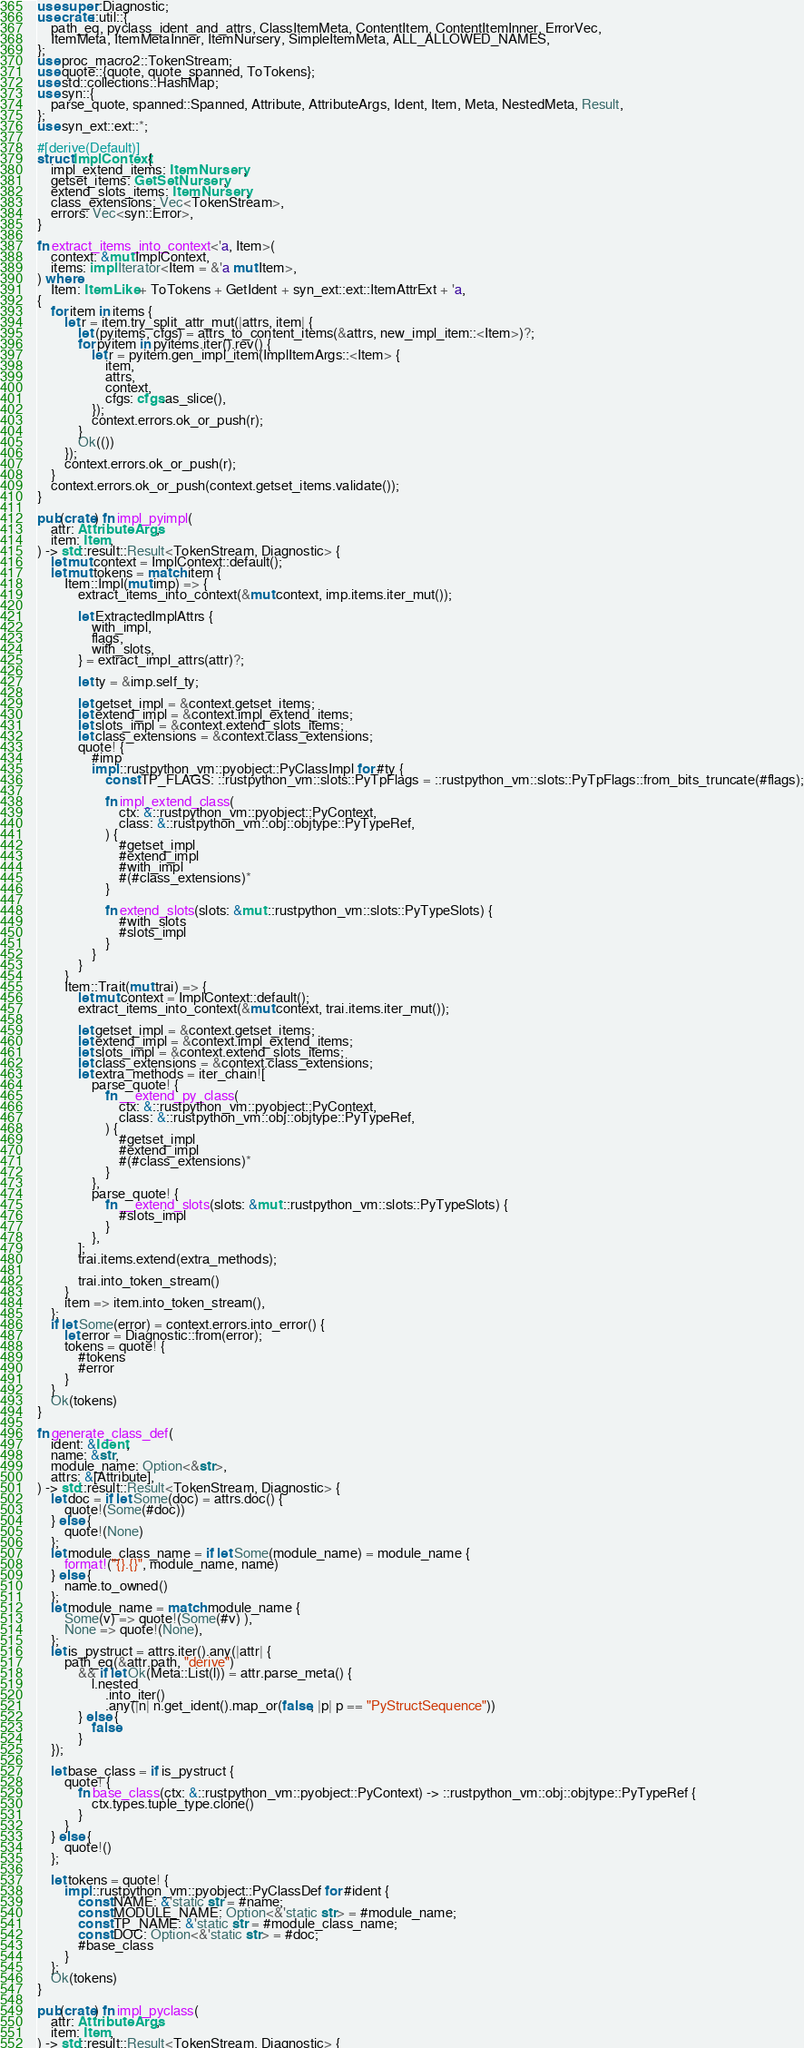Convert code to text. <code><loc_0><loc_0><loc_500><loc_500><_Rust_>use super::Diagnostic;
use crate::util::{
    path_eq, pyclass_ident_and_attrs, ClassItemMeta, ContentItem, ContentItemInner, ErrorVec,
    ItemMeta, ItemMetaInner, ItemNursery, SimpleItemMeta, ALL_ALLOWED_NAMES,
};
use proc_macro2::TokenStream;
use quote::{quote, quote_spanned, ToTokens};
use std::collections::HashMap;
use syn::{
    parse_quote, spanned::Spanned, Attribute, AttributeArgs, Ident, Item, Meta, NestedMeta, Result,
};
use syn_ext::ext::*;

#[derive(Default)]
struct ImplContext {
    impl_extend_items: ItemNursery,
    getset_items: GetSetNursery,
    extend_slots_items: ItemNursery,
    class_extensions: Vec<TokenStream>,
    errors: Vec<syn::Error>,
}

fn extract_items_into_context<'a, Item>(
    context: &mut ImplContext,
    items: impl Iterator<Item = &'a mut Item>,
) where
    Item: ItemLike + ToTokens + GetIdent + syn_ext::ext::ItemAttrExt + 'a,
{
    for item in items {
        let r = item.try_split_attr_mut(|attrs, item| {
            let (pyitems, cfgs) = attrs_to_content_items(&attrs, new_impl_item::<Item>)?;
            for pyitem in pyitems.iter().rev() {
                let r = pyitem.gen_impl_item(ImplItemArgs::<Item> {
                    item,
                    attrs,
                    context,
                    cfgs: cfgs.as_slice(),
                });
                context.errors.ok_or_push(r);
            }
            Ok(())
        });
        context.errors.ok_or_push(r);
    }
    context.errors.ok_or_push(context.getset_items.validate());
}

pub(crate) fn impl_pyimpl(
    attr: AttributeArgs,
    item: Item,
) -> std::result::Result<TokenStream, Diagnostic> {
    let mut context = ImplContext::default();
    let mut tokens = match item {
        Item::Impl(mut imp) => {
            extract_items_into_context(&mut context, imp.items.iter_mut());

            let ExtractedImplAttrs {
                with_impl,
                flags,
                with_slots,
            } = extract_impl_attrs(attr)?;

            let ty = &imp.self_ty;

            let getset_impl = &context.getset_items;
            let extend_impl = &context.impl_extend_items;
            let slots_impl = &context.extend_slots_items;
            let class_extensions = &context.class_extensions;
            quote! {
                #imp
                impl ::rustpython_vm::pyobject::PyClassImpl for #ty {
                    const TP_FLAGS: ::rustpython_vm::slots::PyTpFlags = ::rustpython_vm::slots::PyTpFlags::from_bits_truncate(#flags);

                    fn impl_extend_class(
                        ctx: &::rustpython_vm::pyobject::PyContext,
                        class: &::rustpython_vm::obj::objtype::PyTypeRef,
                    ) {
                        #getset_impl
                        #extend_impl
                        #with_impl
                        #(#class_extensions)*
                    }

                    fn extend_slots(slots: &mut ::rustpython_vm::slots::PyTypeSlots) {
                        #with_slots
                        #slots_impl
                    }
                }
            }
        }
        Item::Trait(mut trai) => {
            let mut context = ImplContext::default();
            extract_items_into_context(&mut context, trai.items.iter_mut());

            let getset_impl = &context.getset_items;
            let extend_impl = &context.impl_extend_items;
            let slots_impl = &context.extend_slots_items;
            let class_extensions = &context.class_extensions;
            let extra_methods = iter_chain![
                parse_quote! {
                    fn __extend_py_class(
                        ctx: &::rustpython_vm::pyobject::PyContext,
                        class: &::rustpython_vm::obj::objtype::PyTypeRef,
                    ) {
                        #getset_impl
                        #extend_impl
                        #(#class_extensions)*
                    }
                },
                parse_quote! {
                    fn __extend_slots(slots: &mut ::rustpython_vm::slots::PyTypeSlots) {
                        #slots_impl
                    }
                },
            ];
            trai.items.extend(extra_methods);

            trai.into_token_stream()
        }
        item => item.into_token_stream(),
    };
    if let Some(error) = context.errors.into_error() {
        let error = Diagnostic::from(error);
        tokens = quote! {
            #tokens
            #error
        }
    }
    Ok(tokens)
}

fn generate_class_def(
    ident: &Ident,
    name: &str,
    module_name: Option<&str>,
    attrs: &[Attribute],
) -> std::result::Result<TokenStream, Diagnostic> {
    let doc = if let Some(doc) = attrs.doc() {
        quote!(Some(#doc))
    } else {
        quote!(None)
    };
    let module_class_name = if let Some(module_name) = module_name {
        format!("{}.{}", module_name, name)
    } else {
        name.to_owned()
    };
    let module_name = match module_name {
        Some(v) => quote!(Some(#v) ),
        None => quote!(None),
    };
    let is_pystruct = attrs.iter().any(|attr| {
        path_eq(&attr.path, "derive")
            && if let Ok(Meta::List(l)) = attr.parse_meta() {
                l.nested
                    .into_iter()
                    .any(|n| n.get_ident().map_or(false, |p| p == "PyStructSequence"))
            } else {
                false
            }
    });

    let base_class = if is_pystruct {
        quote! {
            fn base_class(ctx: &::rustpython_vm::pyobject::PyContext) -> ::rustpython_vm::obj::objtype::PyTypeRef {
                ctx.types.tuple_type.clone()
            }
        }
    } else {
        quote!()
    };

    let tokens = quote! {
        impl ::rustpython_vm::pyobject::PyClassDef for #ident {
            const NAME: &'static str = #name;
            const MODULE_NAME: Option<&'static str> = #module_name;
            const TP_NAME: &'static str = #module_class_name;
            const DOC: Option<&'static str> = #doc;
            #base_class
        }
    };
    Ok(tokens)
}

pub(crate) fn impl_pyclass(
    attr: AttributeArgs,
    item: Item,
) -> std::result::Result<TokenStream, Diagnostic> {</code> 